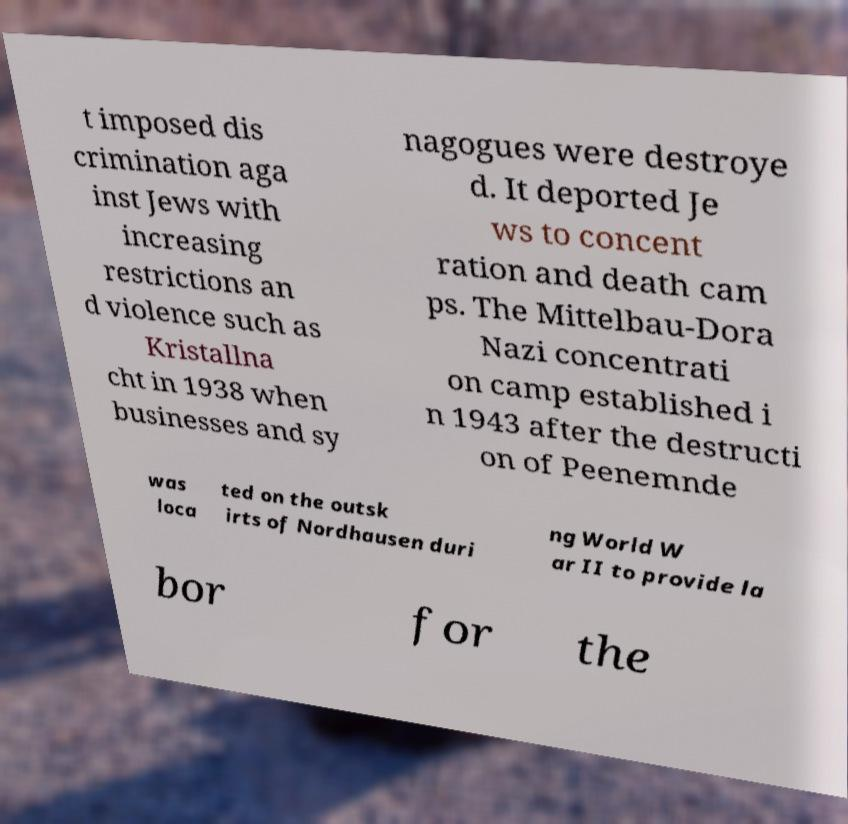Could you extract and type out the text from this image? t imposed dis crimination aga inst Jews with increasing restrictions an d violence such as Kristallna cht in 1938 when businesses and sy nagogues were destroye d. It deported Je ws to concent ration and death cam ps. The Mittelbau-Dora Nazi concentrati on camp established i n 1943 after the destructi on of Peenemnde was loca ted on the outsk irts of Nordhausen duri ng World W ar II to provide la bor for the 